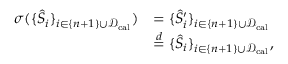<formula> <loc_0><loc_0><loc_500><loc_500>\begin{array} { r l } { \sigma ( \{ \hat { S } _ { i } \} _ { i \in \{ n + 1 \} \cup \mathcal { D } _ { c a l } } ) } & { = \{ \hat { S } _ { i } ^ { \prime } \} _ { i \in \{ n + 1 \} \cup \mathcal { D } _ { c a l } } } \\ & { \overset { d } { = } \{ \hat { S } _ { i } \} _ { i \in \{ n + 1 \} \cup \mathcal { D } _ { c a l } } , } \end{array}</formula> 